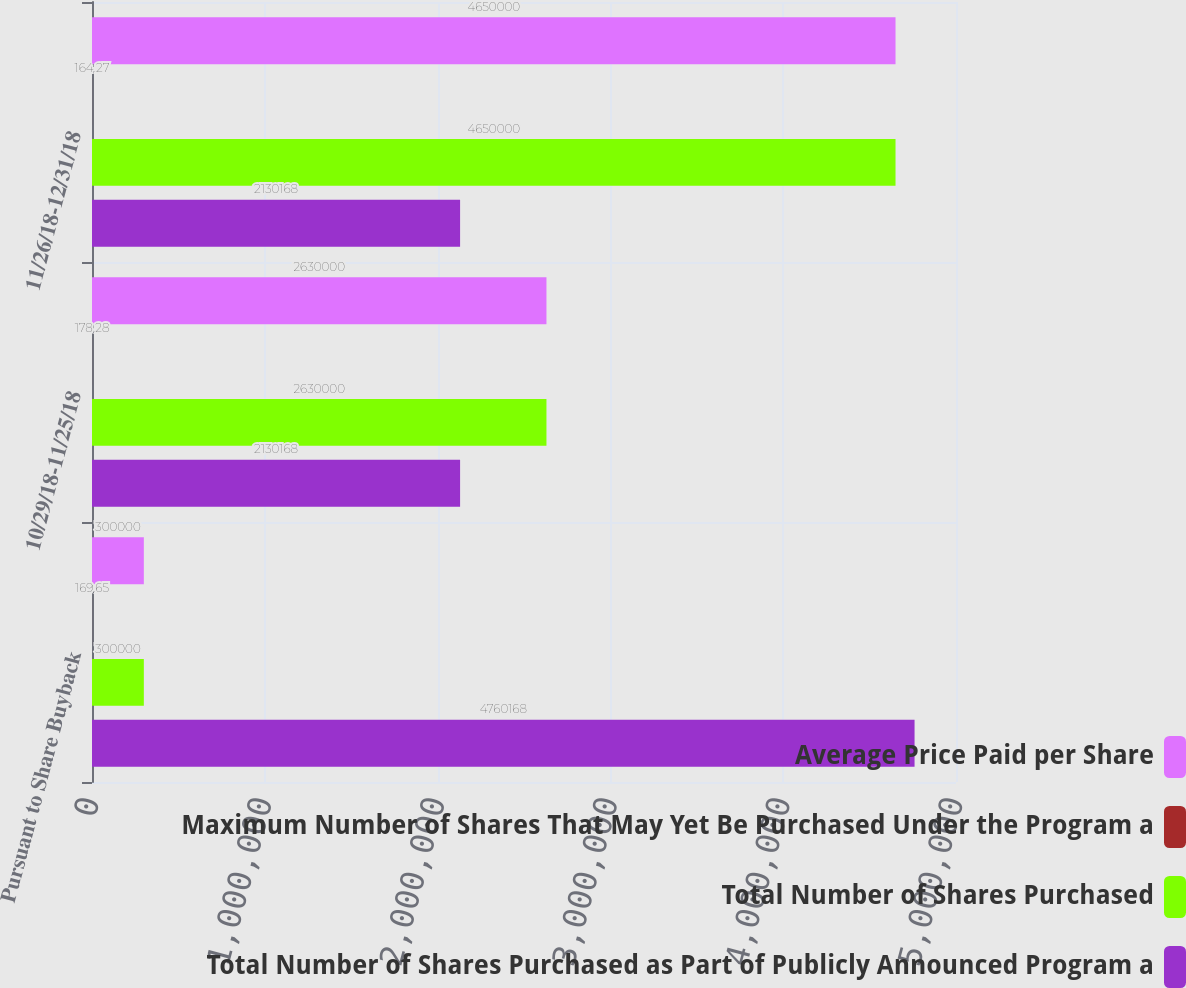Convert chart to OTSL. <chart><loc_0><loc_0><loc_500><loc_500><stacked_bar_chart><ecel><fcel>Pursuant to Share Buyback<fcel>10/29/18-11/25/18<fcel>11/26/18-12/31/18<nl><fcel>Average Price Paid per Share<fcel>300000<fcel>2.63e+06<fcel>4.65e+06<nl><fcel>Maximum Number of Shares That May Yet Be Purchased Under the Program a<fcel>169.65<fcel>178.28<fcel>164.27<nl><fcel>Total Number of Shares Purchased<fcel>300000<fcel>2.63e+06<fcel>4.65e+06<nl><fcel>Total Number of Shares Purchased as Part of Publicly Announced Program a<fcel>4.76017e+06<fcel>2.13017e+06<fcel>2.13017e+06<nl></chart> 